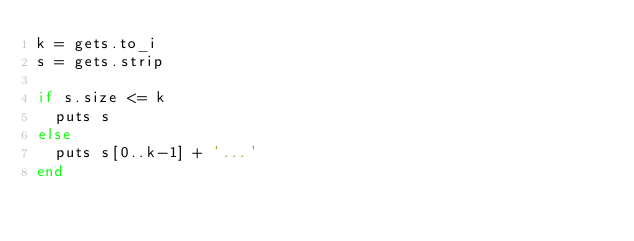Convert code to text. <code><loc_0><loc_0><loc_500><loc_500><_Ruby_>k = gets.to_i
s = gets.strip

if s.size <= k
  puts s
else
  puts s[0..k-1] + '...'
end</code> 